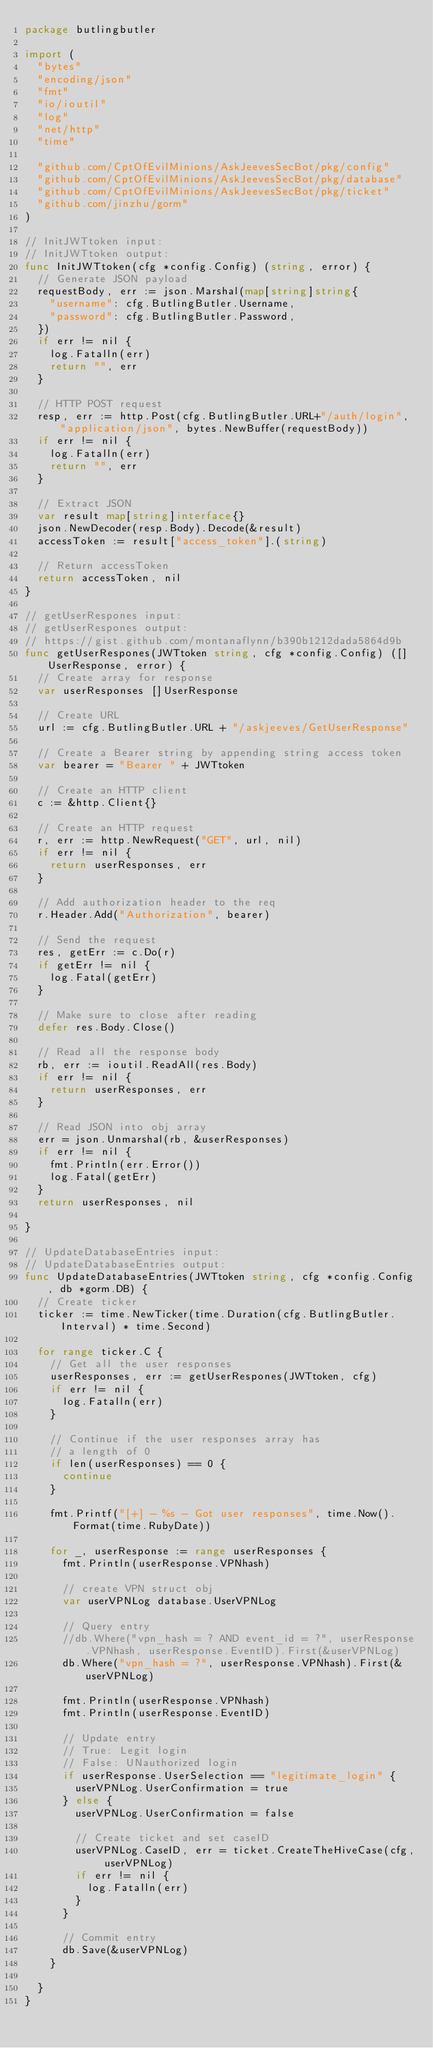<code> <loc_0><loc_0><loc_500><loc_500><_Go_>package butlingbutler

import (
	"bytes"
	"encoding/json"
	"fmt"
	"io/ioutil"
	"log"
	"net/http"
	"time"

	"github.com/CptOfEvilMinions/AskJeevesSecBot/pkg/config"
	"github.com/CptOfEvilMinions/AskJeevesSecBot/pkg/database"
	"github.com/CptOfEvilMinions/AskJeevesSecBot/pkg/ticket"
	"github.com/jinzhu/gorm"
)

// InitJWTtoken input:
// InitJWTtoken output:
func InitJWTtoken(cfg *config.Config) (string, error) {
	// Generate JSON payload
	requestBody, err := json.Marshal(map[string]string{
		"username": cfg.ButlingButler.Username,
		"password": cfg.ButlingButler.Password,
	})
	if err != nil {
		log.Fatalln(err)
		return "", err
	}

	// HTTP POST request
	resp, err := http.Post(cfg.ButlingButler.URL+"/auth/login", "application/json", bytes.NewBuffer(requestBody))
	if err != nil {
		log.Fatalln(err)
		return "", err
	}

	// Extract JSON
	var result map[string]interface{}
	json.NewDecoder(resp.Body).Decode(&result)
	accessToken := result["access_token"].(string)

	// Return accessToken
	return accessToken, nil
}

// getUserRespones input:
// getUserRespones output:
// https://gist.github.com/montanaflynn/b390b1212dada5864d9b
func getUserRespones(JWTtoken string, cfg *config.Config) ([]UserResponse, error) {
	// Create array for response
	var userResponses []UserResponse

	// Create URL
	url := cfg.ButlingButler.URL + "/askjeeves/GetUserResponse"

	// Create a Bearer string by appending string access token
	var bearer = "Bearer " + JWTtoken

	// Create an HTTP client
	c := &http.Client{}

	// Create an HTTP request
	r, err := http.NewRequest("GET", url, nil)
	if err != nil {
		return userResponses, err
	}

	// Add authorization header to the req
	r.Header.Add("Authorization", bearer)

	// Send the request
	res, getErr := c.Do(r)
	if getErr != nil {
		log.Fatal(getErr)
	}

	// Make sure to close after reading
	defer res.Body.Close()

	// Read all the response body
	rb, err := ioutil.ReadAll(res.Body)
	if err != nil {
		return userResponses, err
	}

	// Read JSON into obj array
	err = json.Unmarshal(rb, &userResponses)
	if err != nil {
		fmt.Println(err.Error())
		log.Fatal(getErr)
	}
	return userResponses, nil

}

// UpdateDatabaseEntries input:
// UpdateDatabaseEntries output:
func UpdateDatabaseEntries(JWTtoken string, cfg *config.Config, db *gorm.DB) {
	// Create ticker
	ticker := time.NewTicker(time.Duration(cfg.ButlingButler.Interval) * time.Second)

	for range ticker.C {
		// Get all the user responses
		userResponses, err := getUserRespones(JWTtoken, cfg)
		if err != nil {
			log.Fatalln(err)
		}

		// Continue if the user responses array has
		// a length of 0
		if len(userResponses) == 0 {
			continue
		}

		fmt.Printf("[+] - %s - Got user responses", time.Now().Format(time.RubyDate))

		for _, userResponse := range userResponses {
			fmt.Println(userResponse.VPNhash)

			// create VPN struct obj
			var userVPNLog database.UserVPNLog

			// Query entry
			//db.Where("vpn_hash = ? AND event_id = ?", userResponse.VPNhash, userResponse.EventID).First(&userVPNLog)
			db.Where("vpn_hash = ?", userResponse.VPNhash).First(&userVPNLog)

			fmt.Println(userResponse.VPNhash)
			fmt.Println(userResponse.EventID)

			// Update entry
			// True: Legit login
			// False: UNauthorized login
			if userResponse.UserSelection == "legitimate_login" {
				userVPNLog.UserConfirmation = true
			} else {
				userVPNLog.UserConfirmation = false

				// Create ticket and set caseID
				userVPNLog.CaseID, err = ticket.CreateTheHiveCase(cfg, userVPNLog)
				if err != nil {
					log.Fatalln(err)
				}
			}

			// Commit entry
			db.Save(&userVPNLog)
		}

	}
}
</code> 